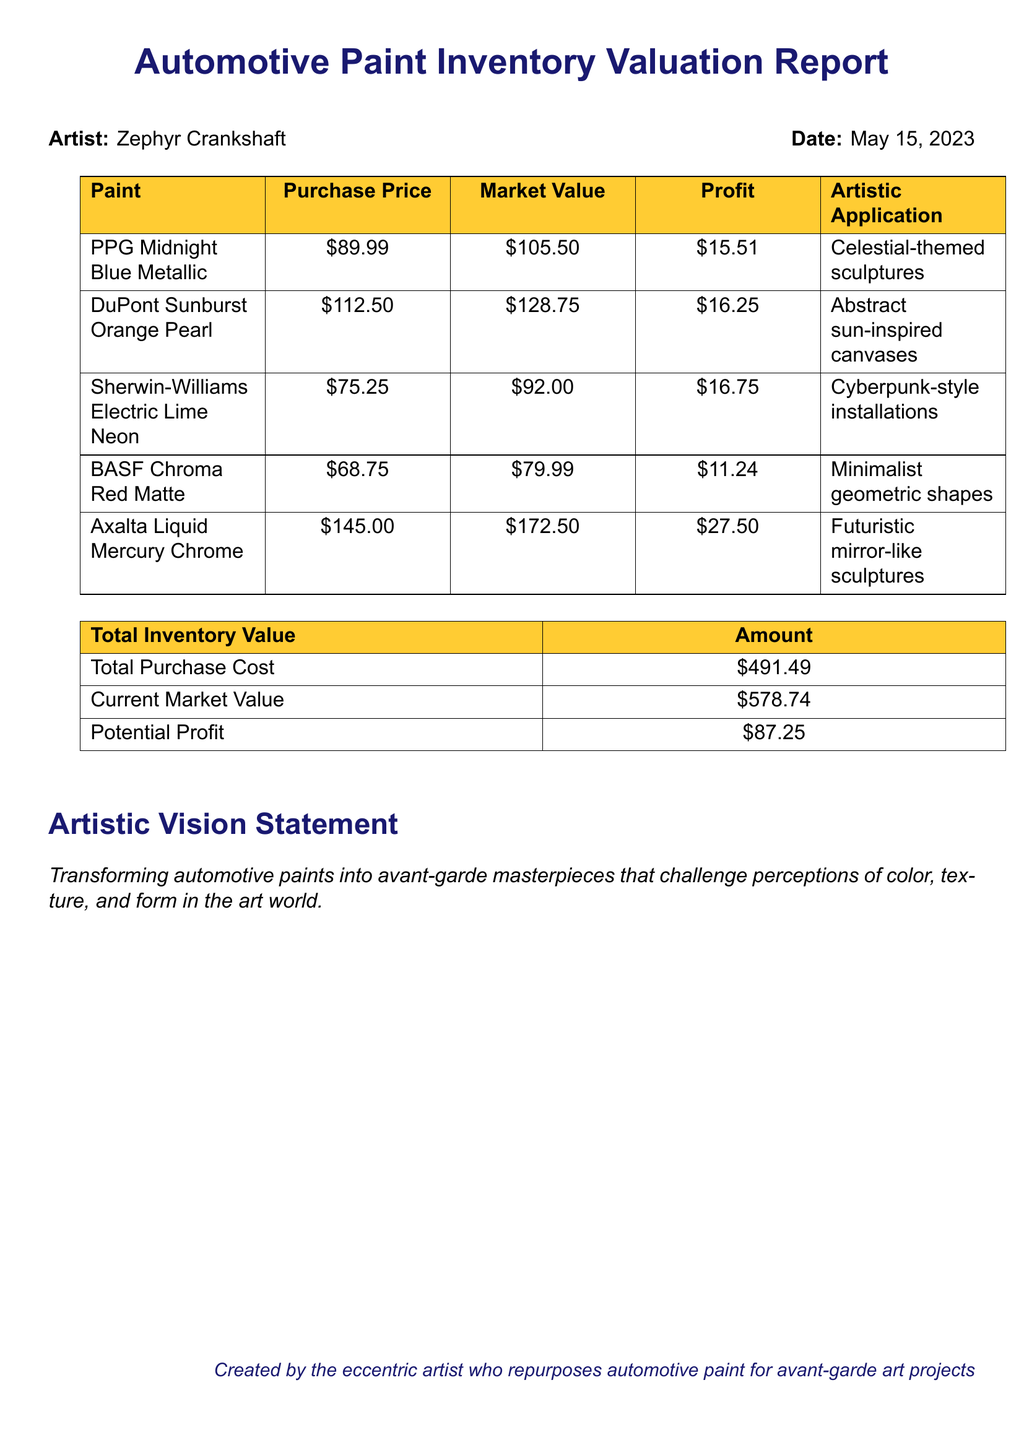What is the report date? The report date is stated at the beginning of the document, which is May 15, 2023.
Answer: May 15, 2023 What is the purchase price of Electric Lime? The purchase price of Electric Lime is listed in the paint inventory section of the document.
Answer: 75.25 What brand offers Liquid Mercury? The brand associated with Liquid Mercury can be found in the paint inventory list.
Answer: Axalta What is the potential profit? Potential profit is calculated as the difference between the total current market value and total purchase cost.
Answer: 87.25 Which color is used for celestial-themed sculptures? The artistic application for celestial-themed sculptures is mentioned alongside its respective paint color.
Answer: Midnight Blue Metallic What is the current market value of Chroma Red? The current market value for Chroma Red is provided in the financial report details.
Answer: 79.99 Which finish is associated with Sunburst Orange? The finish of Sunburst Orange is specified in the paint inventory table.
Answer: Pearl How much is the total purchase cost? The total purchase cost is stated in the summary of total inventory value.
Answer: 491.49 What does the artistic vision statement express? The artistic vision statement encapsulates the aim and style of the artist's work mentioned in the document.
Answer: Transforming automotive paints into avant-garde masterpieces that challenge perceptions of color, texture, and form in the art world 